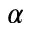<formula> <loc_0><loc_0><loc_500><loc_500>\alpha</formula> 